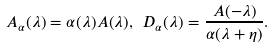<formula> <loc_0><loc_0><loc_500><loc_500>A _ { \alpha } ( \lambda ) = \alpha ( \lambda ) A ( \lambda ) , \text {\ } D _ { \alpha } ( \lambda ) = \frac { A ( - \lambda ) } { \alpha ( \lambda + \eta ) } .</formula> 